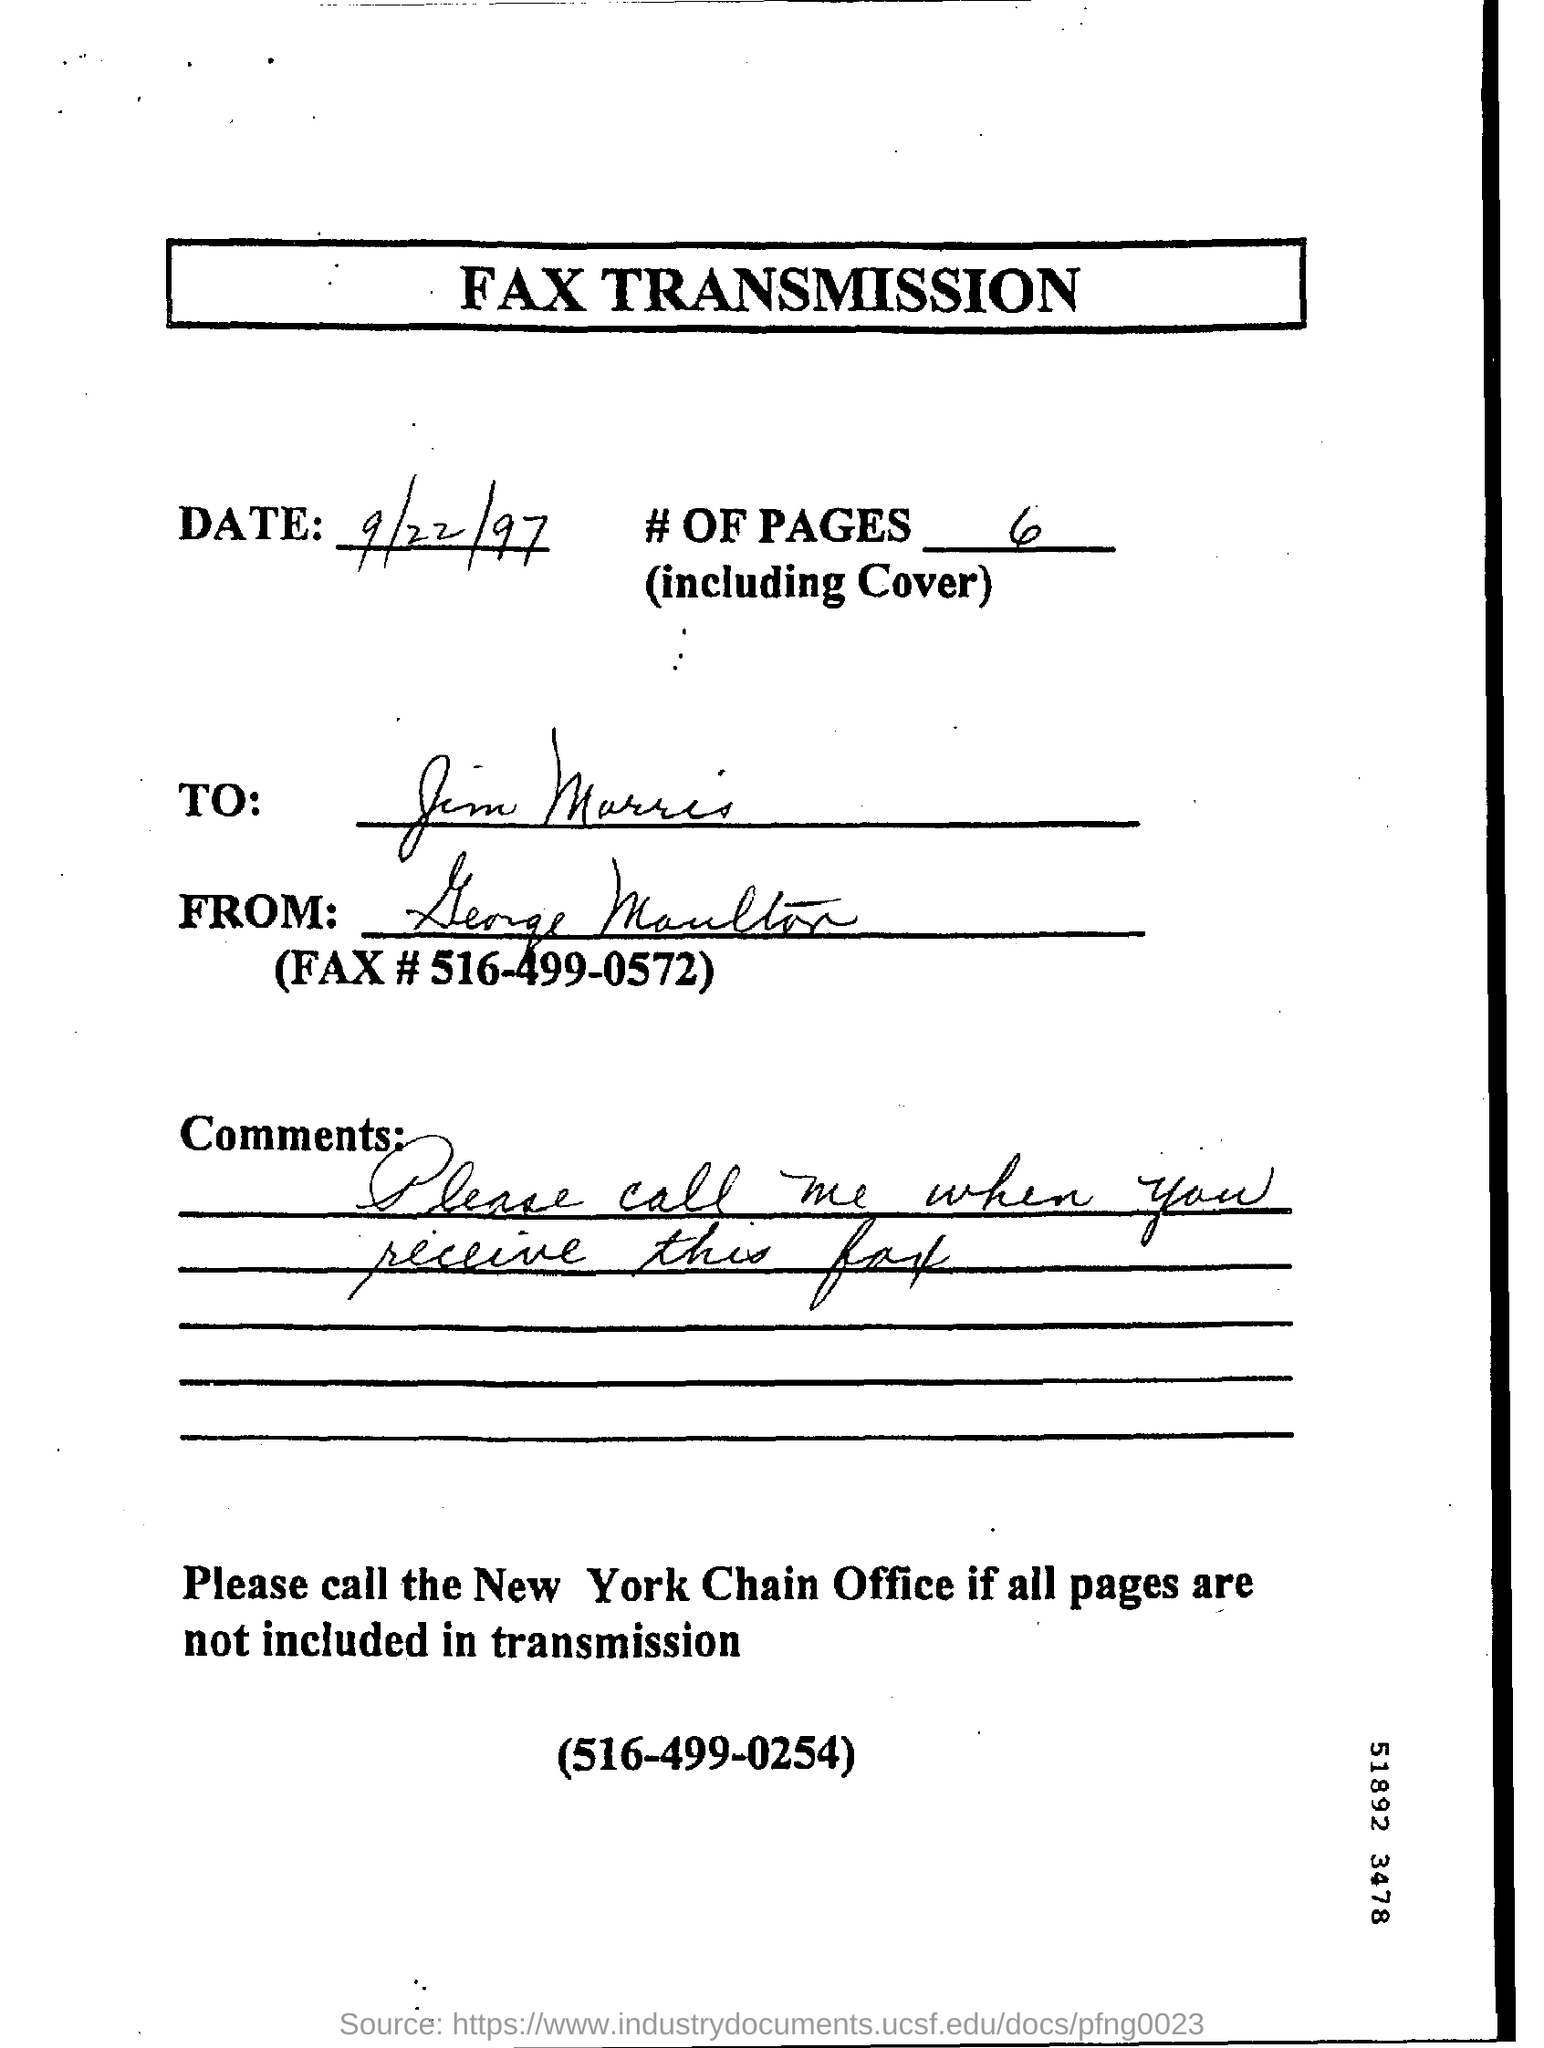Highlight a few significant elements in this photo. There are 6 pages in the given fax. The New York office number mentioned in the FAX is 516-499-0254. 